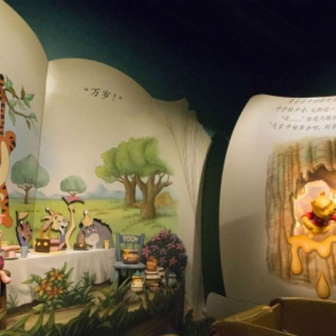How might the scene change if it were nighttime? If the scene were set at nighttime, the mural might depict a serene and quiet setting under a starry sky. The tree could be bathed in the soft glow of moonlight, with fireflies adding magical little sparks of light around. Winnie the Pooh might be seen holding a lantern, the warm light reflecting on his face as he reaches for the honey pot. Tigger could be gazing up at the stars, dreaming about his next adventure. Piglet, staying close to Pooh, might have a tiny candle to keep the darkness at bay. Eeyore, perhaps lying down, would be watching the nocturnal scene with his usual pensiveness. The overall ambiance would shift to a calm and soothing night in the Hundred Acre Wood, evoking a sense of tranquility and wonder. If you were to write a poem about this scene, how would it go? Beneath the tree in verdant green,
A place where woodland dreams convene,
There stands our Pooh in red attire,
With honeyed hopes, his heart aspire.

Tigger leaps with boundless glee,
His stripes a blur for all to see,
Piglet small with courage shy,
In friends' embrace finds strength to try.

Eeyore sighs with gentle grace,
In this calm and peaceful place,
A mural bright with tales of yore,
In colors rich and evermore.

The tree above, its branches wide,
A shelter where these friends abide,
In English, Japanese, and art so grand,
A story timeless, hand in hand. Create an imaginative dialogue where Tigger invents a new game for everyone. Tigger: "Hey, everyone! I've got a stupendous idea for a game! I call it 'Bounce and Find!'"

Pooh: "Bounce and find? How do we play, Tigger?"

Tigger: *grinning* "It's easy! We all take turns bouncing around the Hundred Acre Wood. While we bounce, we look for hidden treasures like honey pots, flowers, and colorful stones. Whoever finds the most treasures wins!"

Piglet: "Oh dear, it sounds a bit challenging... but I'll try!"

Eeyore: "Doesn’t matter if I join or not. I’m sure to lose anyway, but I'll give it a go."

Tigger: "That's the spirit, Eeyore! Ready, set, bounce!"
(The friends start bouncing around, laughing and exclaiming as they find various treasures, enjoying the fun and adventure of Tigger's new game.) Describe a highly detailed and imaginative scenario involving the mural. As the sun dipped below the horizon, casting long shadows across the Hundred Acre Wood, a magical glow began to emanate from the mural. The characters, once static, began to move. Pooh, reaching for his honey pot, suddenly found it brimming with golden, shimmering honey that sparkled like diamonds. He dipped his paw in and tasted, exclaiming, 'Oh, bother! This isn't just any honey; it's enchanted honey!'

Tigger bounced energetically, his stripes glowing neon as he leaped with a newfound lightness, almost as if he could fly. 'Wow, this is Tigger’s dream come true!' he shouted, soaring through the air.

Piglet, at first hesitant, discovered that his stripes had turned into a soft pink hue that glowed softly in the dusky light. 'Oh, my! I feel braver than I've ever felt!' he whispered, taking tentative steps that soon turned into joyful skips.

Eeyore, whose usually gray coat was now shimmering with a silvery sheen, found a treasure chest hidden under the mural’s tree. As he opened it, he discovered not just gold, but letters and gifts from his friends, tokens of their love and friendship, which brought a rare smile to his face. 'They do care,' he murmured.

The scene around them transformed into a whimsical night parade, with glowing lanterns hanging from the tree, casting a warm, gentle light. The text in Japanese and English twinkled, sharing messages of friendship and adventure that floated in the air like fairy dust. The mural had come alive, capturing the magic and essence of their adventures, reminding them of the joy that comes from shared moments and treasured friendships. Their laughter echoed through the night, a symphony of pure happiness and wonder. Describe a realistic scenario involving the mural. Families visiting the children's play area gather around the mural, children pointing excitedly at their favorite characters. A parent sits on a nearby bench, reading the story of Winnie the Pooh aloud as the children listen intently, their eyes wide with wonder. Some kids mimic Tigger's bouncing, while others pretend to search for honey like Pooh. The mural serves as a backdrop for photos, capturing joyful memories of a day spent in the company of timeless characters. 